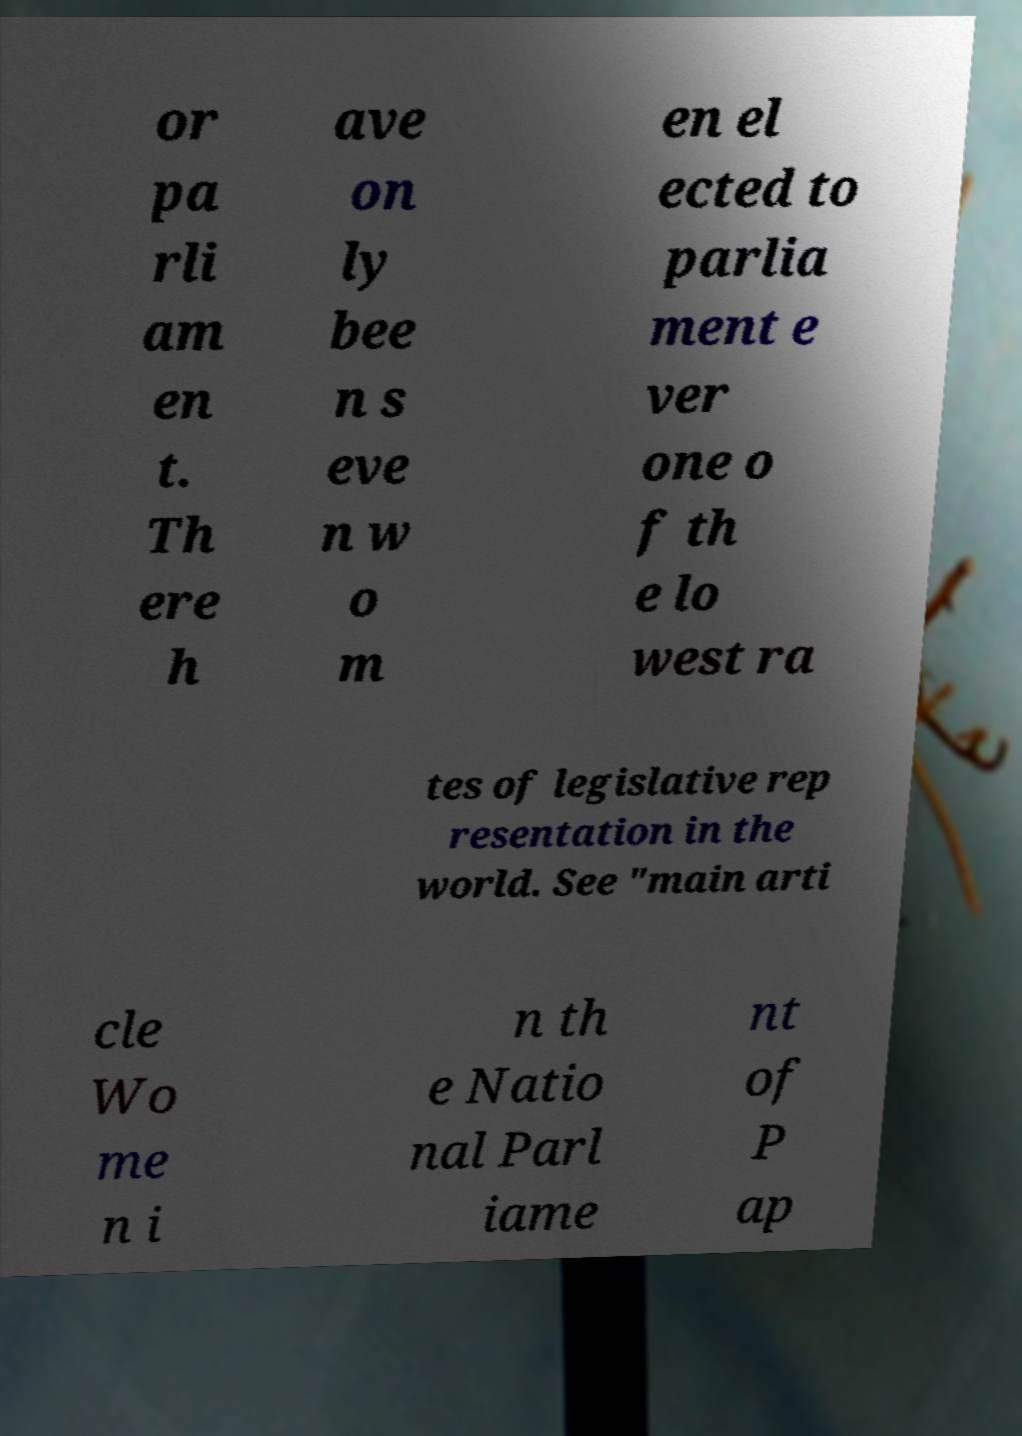For documentation purposes, I need the text within this image transcribed. Could you provide that? or pa rli am en t. Th ere h ave on ly bee n s eve n w o m en el ected to parlia ment e ver one o f th e lo west ra tes of legislative rep resentation in the world. See "main arti cle Wo me n i n th e Natio nal Parl iame nt of P ap 